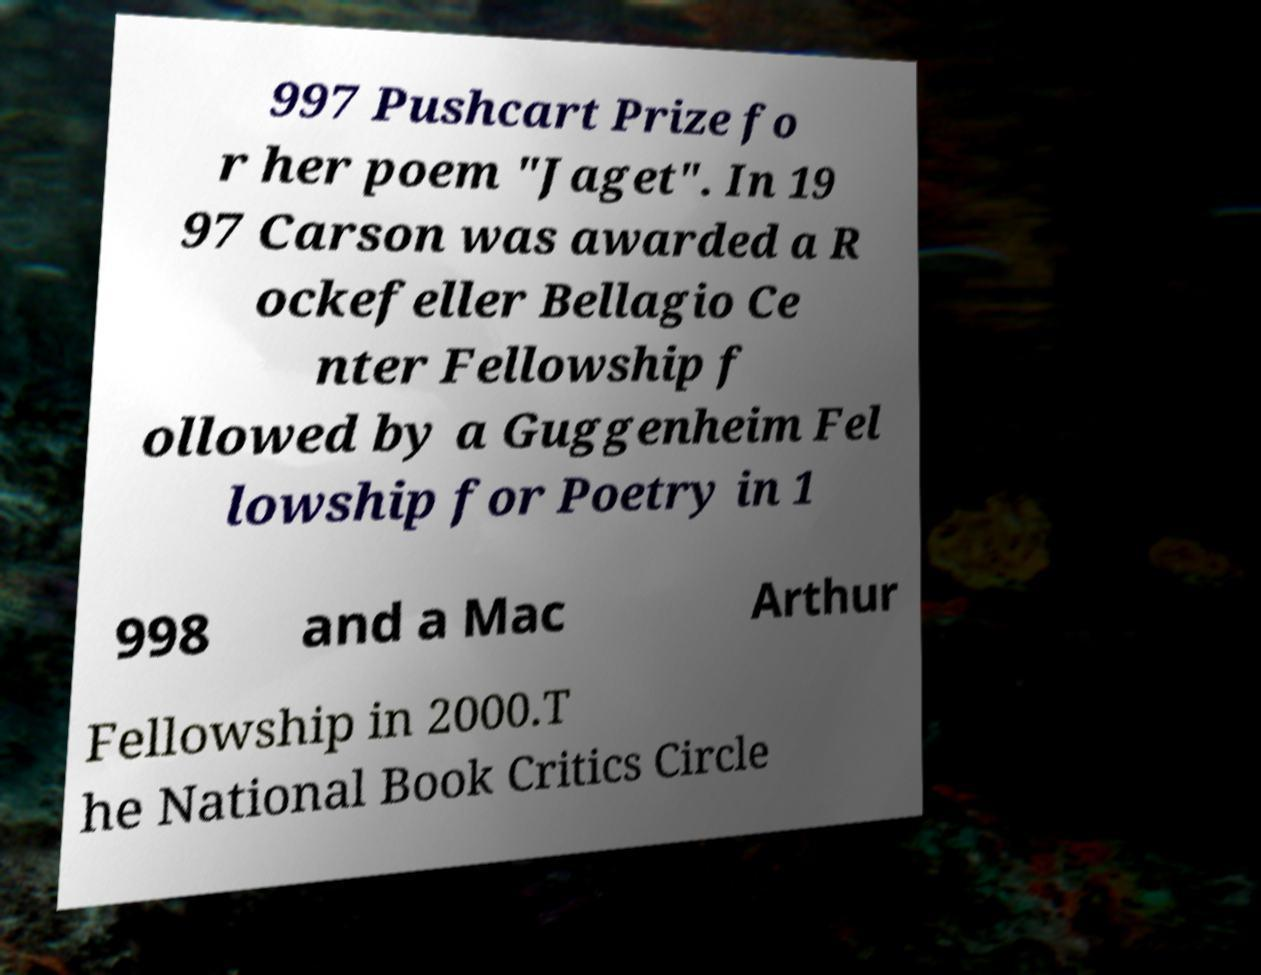For documentation purposes, I need the text within this image transcribed. Could you provide that? 997 Pushcart Prize fo r her poem "Jaget". In 19 97 Carson was awarded a R ockefeller Bellagio Ce nter Fellowship f ollowed by a Guggenheim Fel lowship for Poetry in 1 998 and a Mac Arthur Fellowship in 2000.T he National Book Critics Circle 